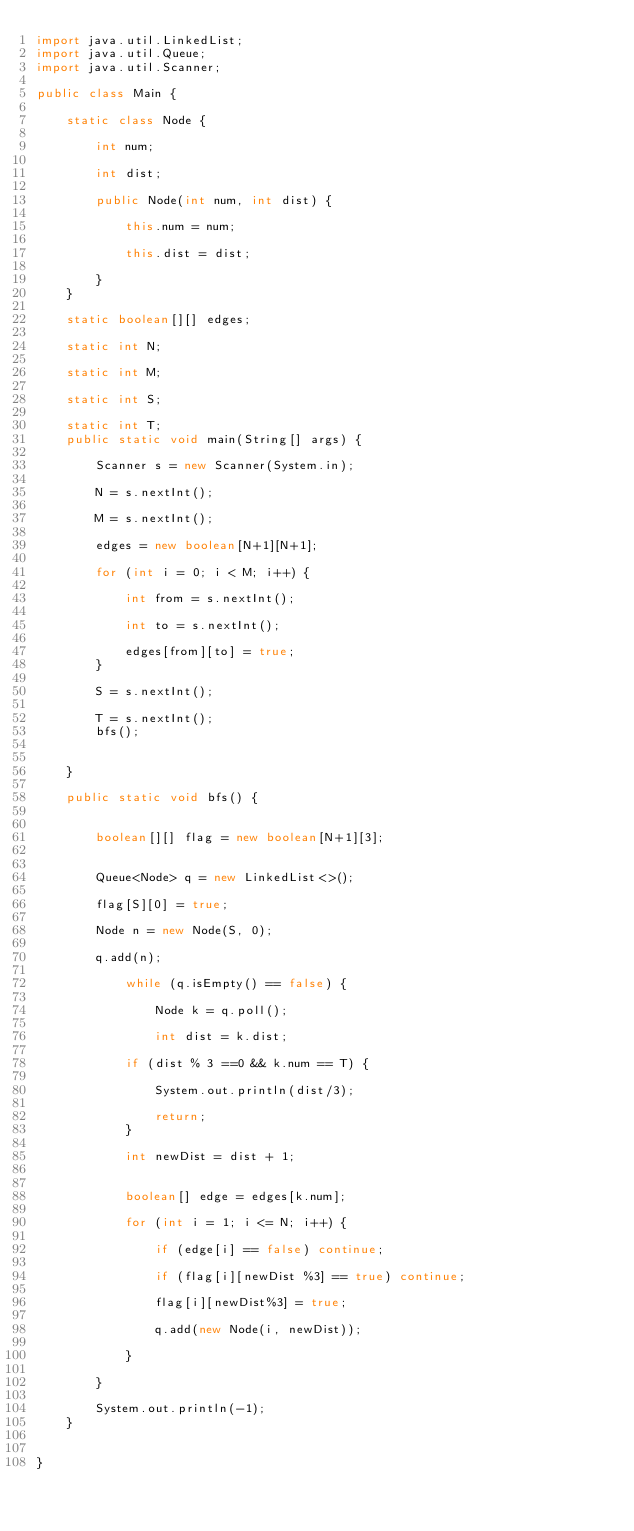Convert code to text. <code><loc_0><loc_0><loc_500><loc_500><_Java_>import java.util.LinkedList;
import java.util.Queue;
import java.util.Scanner;

public class Main {

    static class Node {

        int num;

        int dist;

        public Node(int num, int dist) {

            this.num = num;

            this.dist = dist;

        }
    }

    static boolean[][] edges;

    static int N;

    static int M;

    static int S;

    static int T;
    public static void main(String[] args) {

        Scanner s = new Scanner(System.in);

        N = s.nextInt();

        M = s.nextInt();

        edges = new boolean[N+1][N+1];

        for (int i = 0; i < M; i++) {

            int from = s.nextInt();

            int to = s.nextInt();

            edges[from][to] = true;
        }

        S = s.nextInt();

        T = s.nextInt();
        bfs();


    }

    public static void bfs() {


        boolean[][] flag = new boolean[N+1][3];


        Queue<Node> q = new LinkedList<>();

        flag[S][0] = true;

        Node n = new Node(S, 0);

        q.add(n);

            while (q.isEmpty() == false) {

                Node k = q.poll();

                int dist = k.dist;

            if (dist % 3 ==0 && k.num == T) {

                System.out.println(dist/3);

                return;
            }

            int newDist = dist + 1;


            boolean[] edge = edges[k.num];

            for (int i = 1; i <= N; i++) {

                if (edge[i] == false) continue;

                if (flag[i][newDist %3] == true) continue;

                flag[i][newDist%3] = true;

                q.add(new Node(i, newDist));

            }

        }

        System.out.println(-1);
    }


}
</code> 